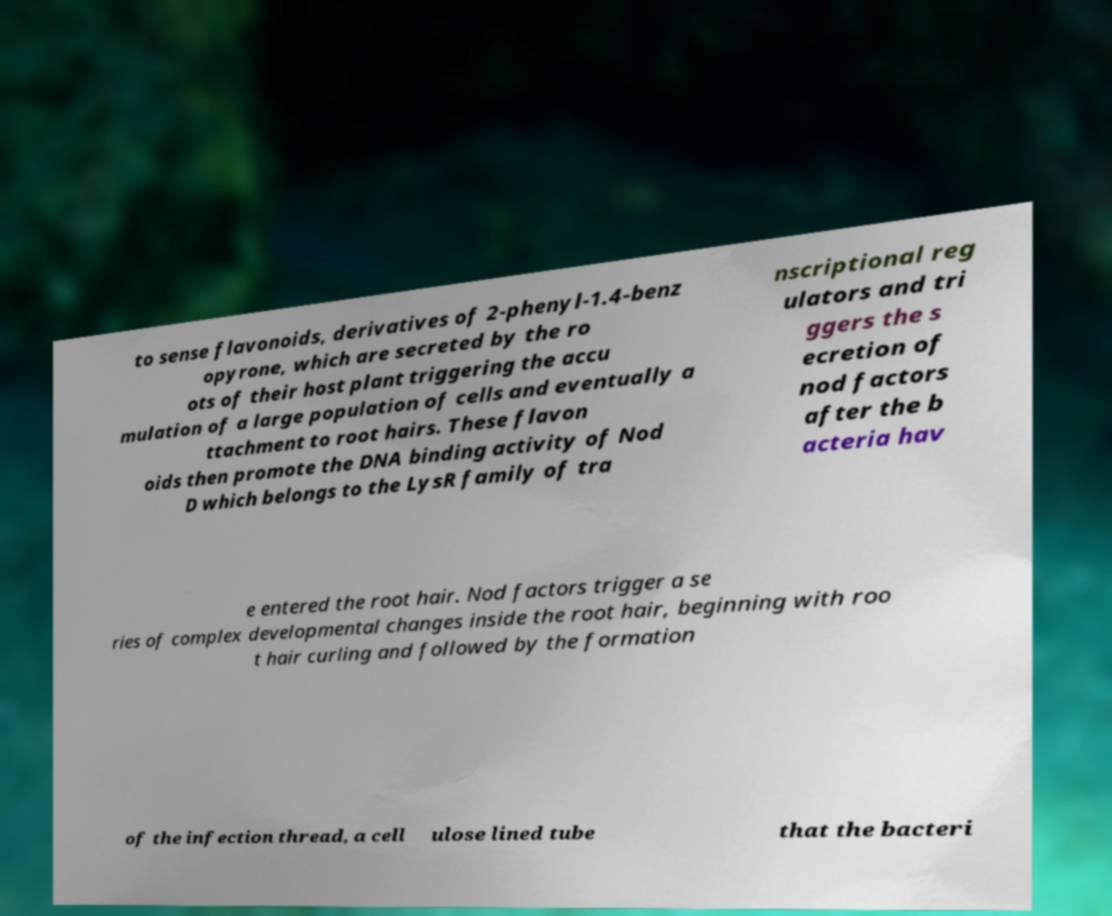Please read and relay the text visible in this image. What does it say? to sense flavonoids, derivatives of 2-phenyl-1.4-benz opyrone, which are secreted by the ro ots of their host plant triggering the accu mulation of a large population of cells and eventually a ttachment to root hairs. These flavon oids then promote the DNA binding activity of Nod D which belongs to the LysR family of tra nscriptional reg ulators and tri ggers the s ecretion of nod factors after the b acteria hav e entered the root hair. Nod factors trigger a se ries of complex developmental changes inside the root hair, beginning with roo t hair curling and followed by the formation of the infection thread, a cell ulose lined tube that the bacteri 